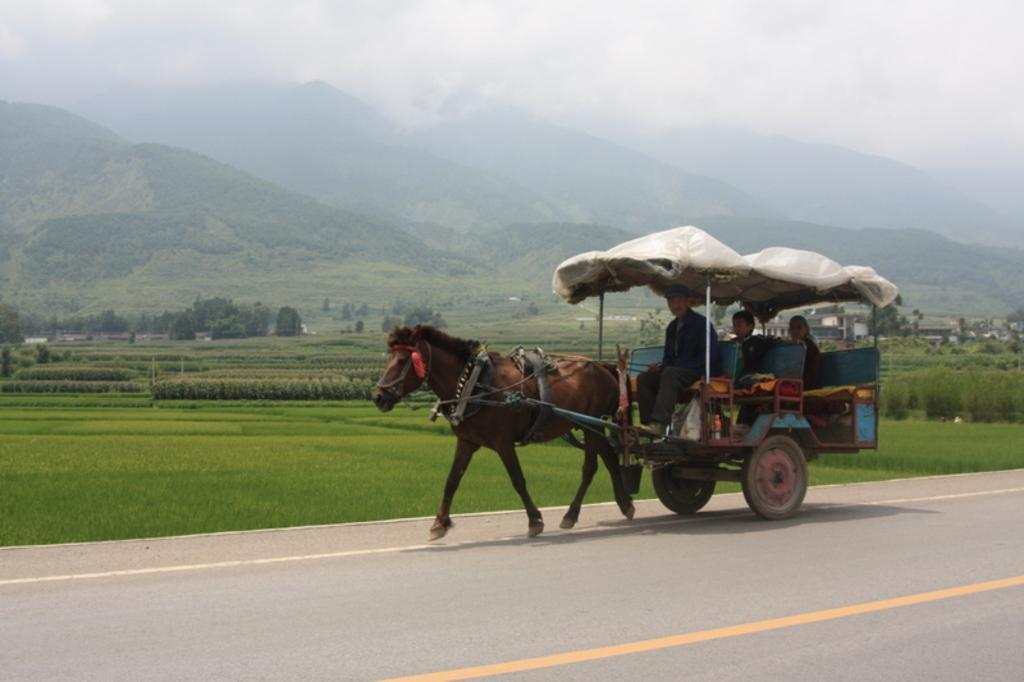What is the main subject of the image? The main subject of the image is a horse with a cart. How many people are in the horse cart? There are three persons sitting in the horse cart. What type of vegetation can be seen in the image? There is grass, plants, and trees in the image. What type of structures are visible in the image? There are houses in the image. What type of geographical feature can be seen in the image? There are hills in the image. What is visible in the background of the image? The sky is visible in the background of the image. What type of clocks can be seen hanging from the trees in the image? There are no clocks visible in the image, and no clocks are hanging from the trees. 